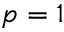Convert formula to latex. <formula><loc_0><loc_0><loc_500><loc_500>p = 1</formula> 